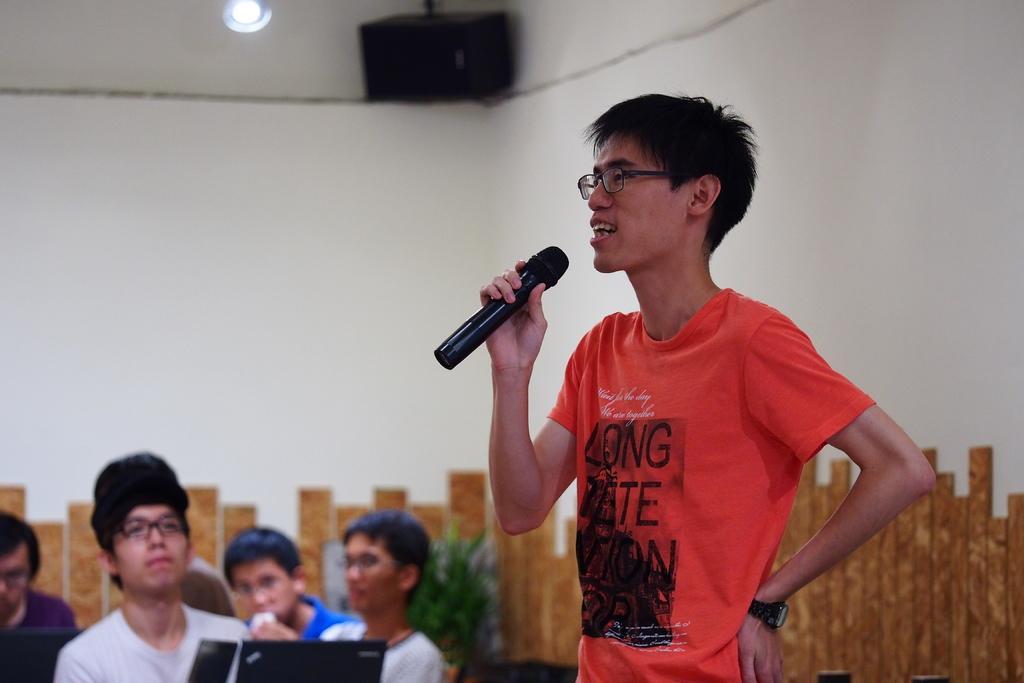Could you give a brief overview of what you see in this image? This red t-shirt person wore spectacles and holds a mic. Far there are plants. On the top there is a sound box. This persons are sitting on a chair. In-front of this person there is a laptop. 